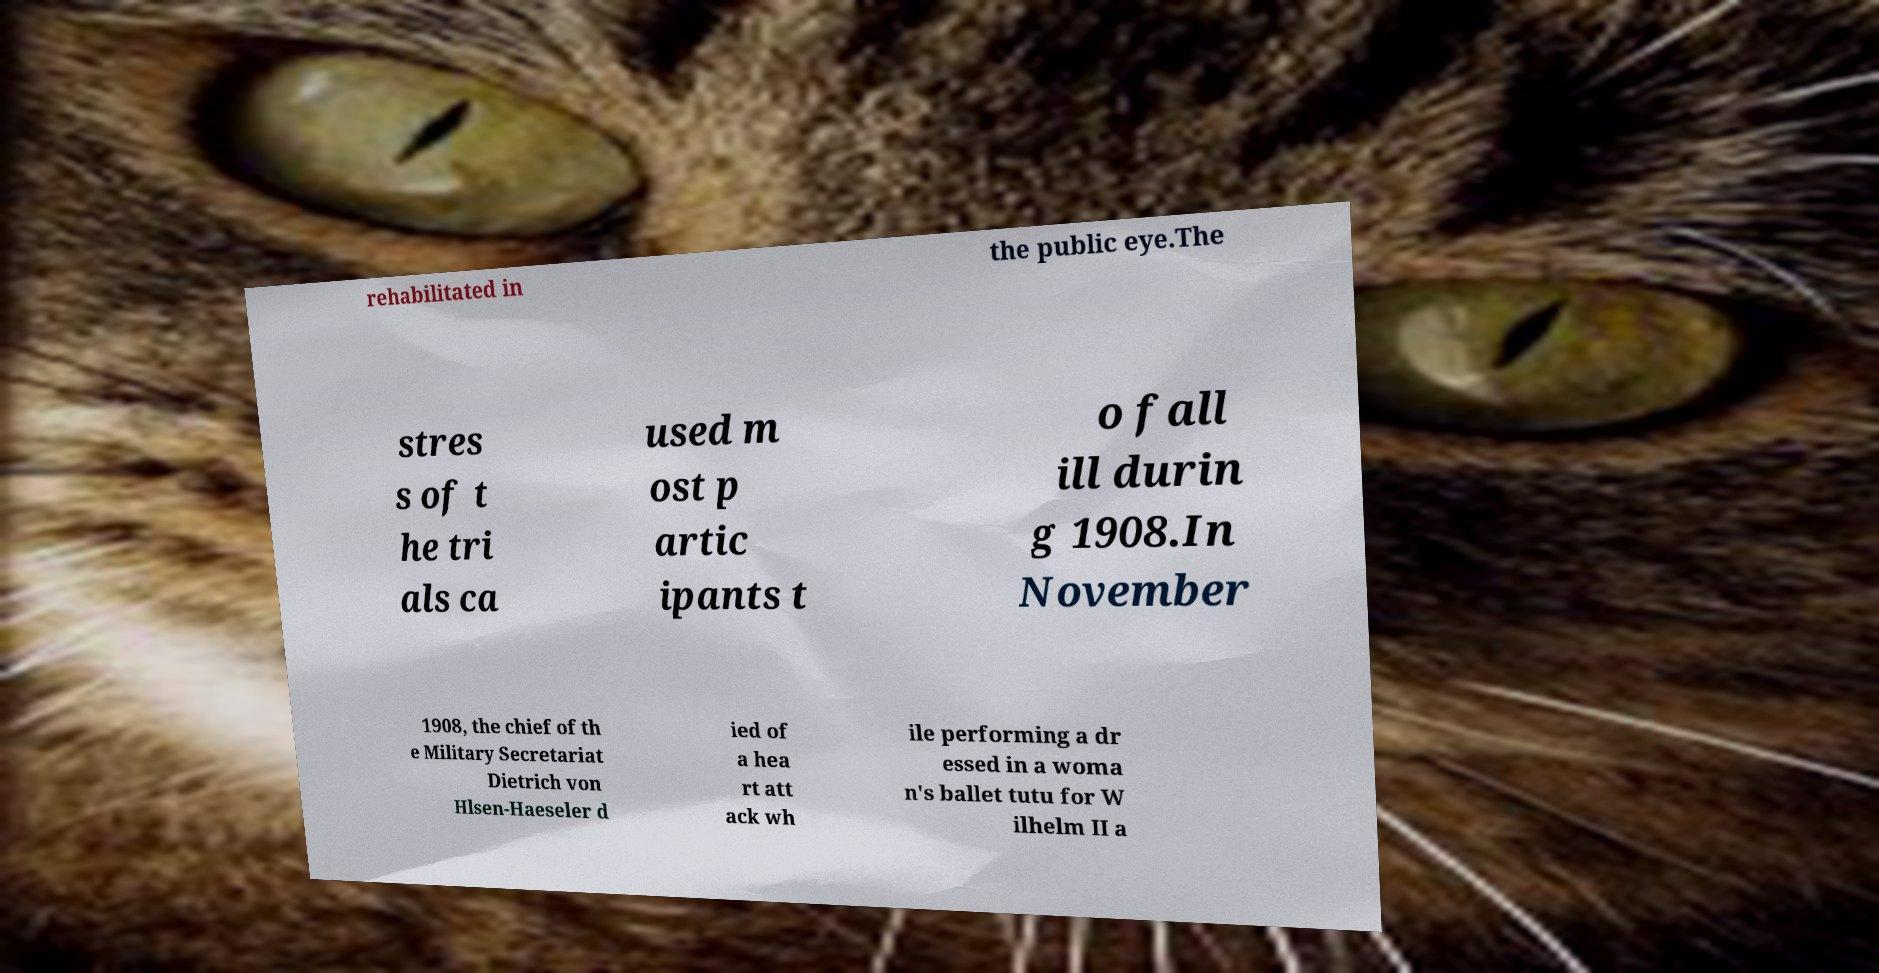What messages or text are displayed in this image? I need them in a readable, typed format. rehabilitated in the public eye.The stres s of t he tri als ca used m ost p artic ipants t o fall ill durin g 1908.In November 1908, the chief of th e Military Secretariat Dietrich von Hlsen-Haeseler d ied of a hea rt att ack wh ile performing a dr essed in a woma n's ballet tutu for W ilhelm II a 